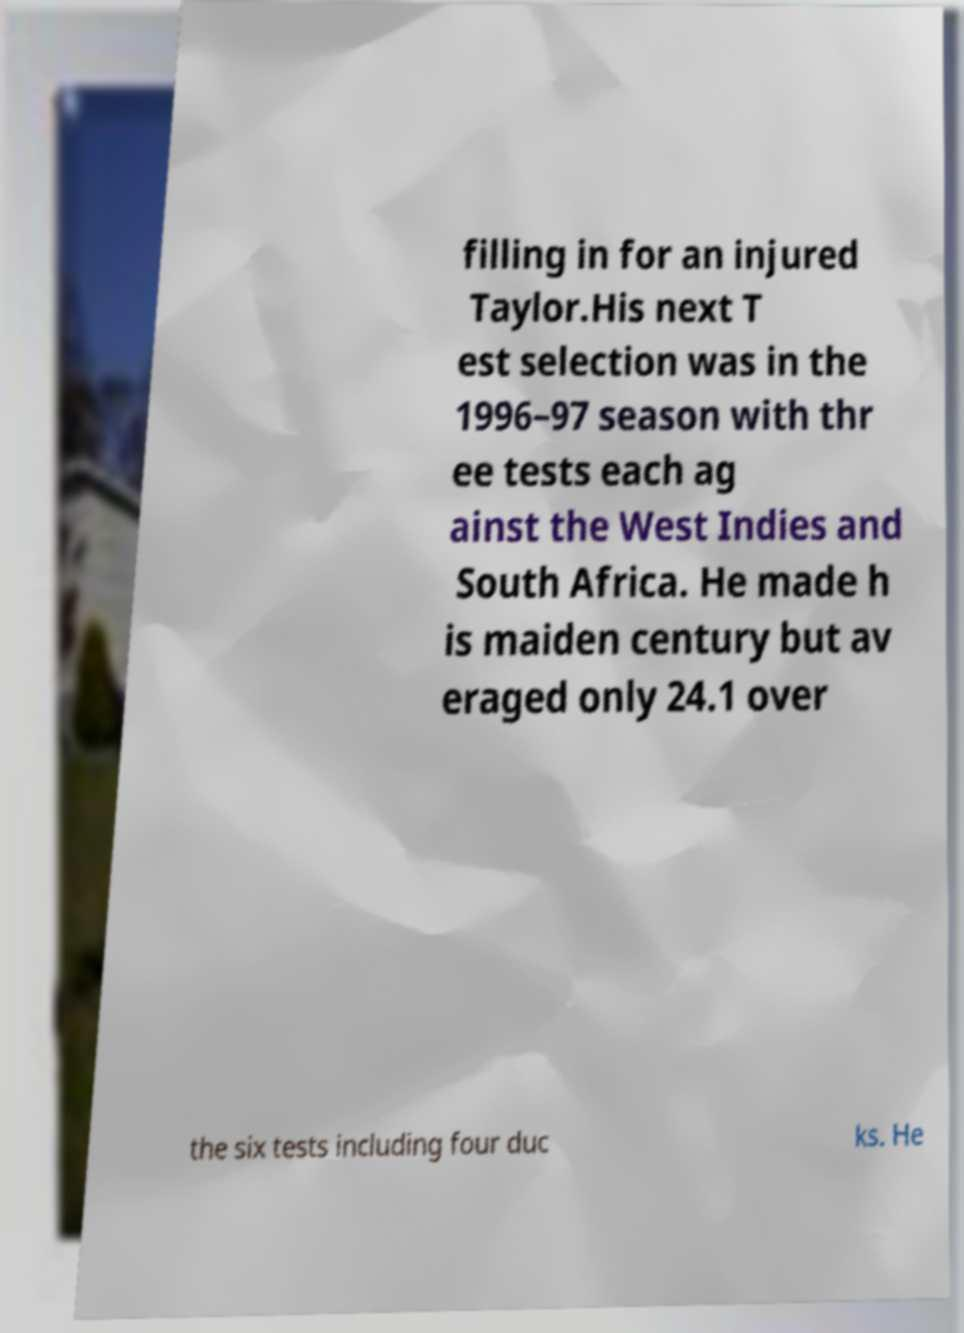Please identify and transcribe the text found in this image. filling in for an injured Taylor.His next T est selection was in the 1996–97 season with thr ee tests each ag ainst the West Indies and South Africa. He made h is maiden century but av eraged only 24.1 over the six tests including four duc ks. He 